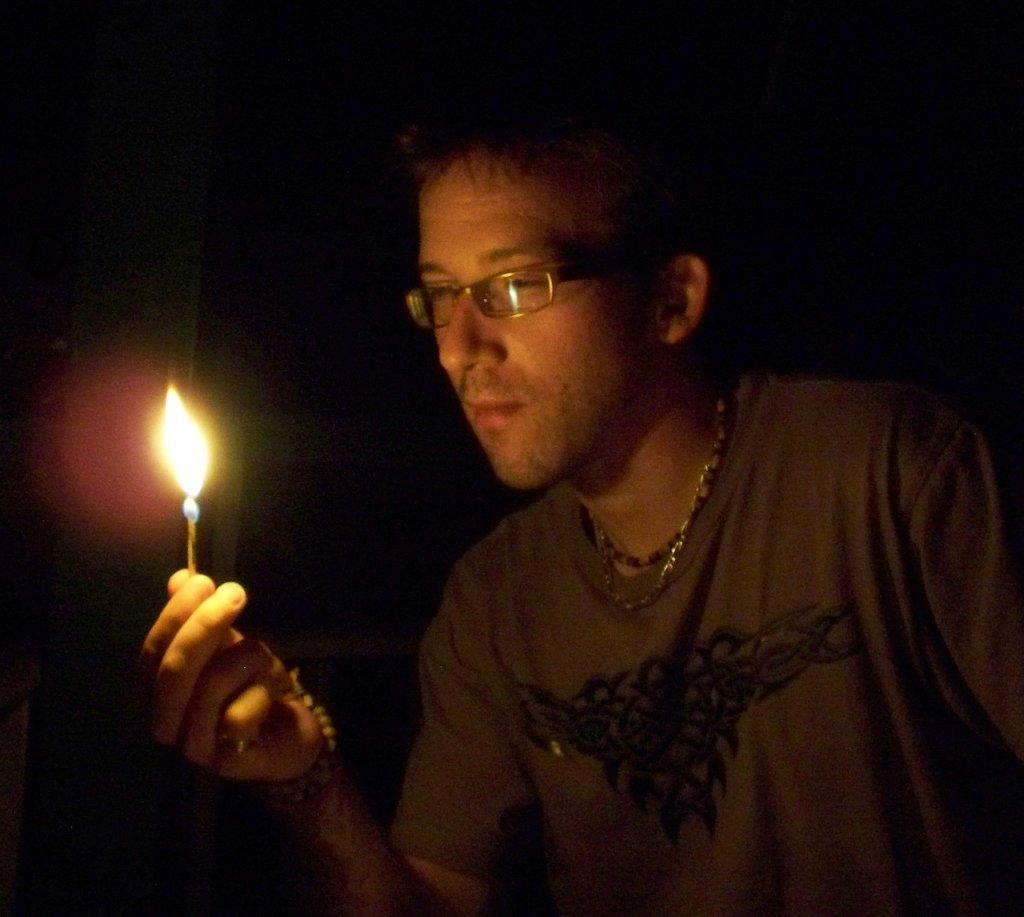Who is present in the image? There is a man in the image. What can be observed about the man's appearance? The man is wearing glasses and a t-shirt. What is the man holding in the image? The man is holding a matchstick with a flame. What is the color of the background in the image? The background of the image is black. What type of tax is being discussed in the image? There is no discussion of tax in the image; it features a man holding a matchstick with a flame. Can you see any ants in the image? There are no ants present in the image. 